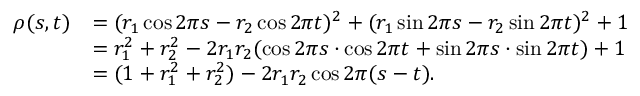Convert formula to latex. <formula><loc_0><loc_0><loc_500><loc_500>\begin{array} { r l } { \rho ( s , t ) } & { = ( r _ { 1 } \cos 2 \pi s - r _ { 2 } \cos 2 \pi t ) ^ { 2 } + ( r _ { 1 } \sin 2 \pi s - r _ { 2 } \sin 2 \pi t ) ^ { 2 } + 1 } \\ & { = r _ { 1 } ^ { 2 } + r _ { 2 } ^ { 2 } - 2 r _ { 1 } r _ { 2 } ( \cos 2 \pi s \cdot \cos 2 \pi t + \sin 2 \pi s \cdot \sin 2 \pi t ) + 1 } \\ & { = ( 1 + r _ { 1 } ^ { 2 } + r _ { 2 } ^ { 2 } ) - 2 r _ { 1 } r _ { 2 } \cos 2 \pi ( s - t ) . } \end{array}</formula> 